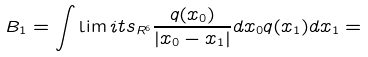Convert formula to latex. <formula><loc_0><loc_0><loc_500><loc_500>B _ { 1 } = \int \lim i t s _ { R ^ { 6 } } \frac { q ( x _ { 0 } ) } { | x _ { 0 } - x _ { 1 } | } d x _ { 0 } q ( x _ { 1 } ) d x _ { 1 } =</formula> 